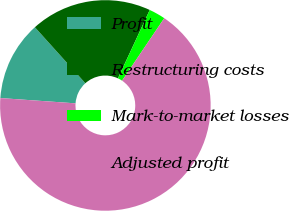<chart> <loc_0><loc_0><loc_500><loc_500><pie_chart><fcel>Profit<fcel>Restructuring costs<fcel>Mark-to-market losses<fcel>Adjusted profit<nl><fcel>12.21%<fcel>18.6%<fcel>2.52%<fcel>66.67%<nl></chart> 